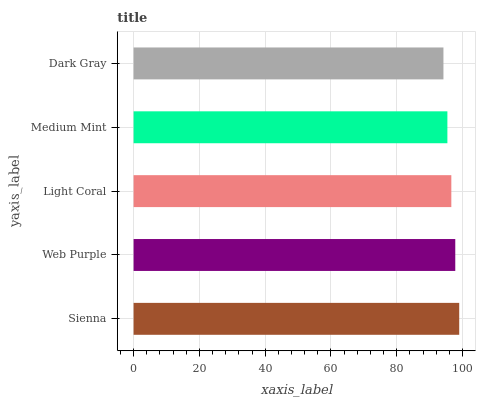Is Dark Gray the minimum?
Answer yes or no. Yes. Is Sienna the maximum?
Answer yes or no. Yes. Is Web Purple the minimum?
Answer yes or no. No. Is Web Purple the maximum?
Answer yes or no. No. Is Sienna greater than Web Purple?
Answer yes or no. Yes. Is Web Purple less than Sienna?
Answer yes or no. Yes. Is Web Purple greater than Sienna?
Answer yes or no. No. Is Sienna less than Web Purple?
Answer yes or no. No. Is Light Coral the high median?
Answer yes or no. Yes. Is Light Coral the low median?
Answer yes or no. Yes. Is Web Purple the high median?
Answer yes or no. No. Is Medium Mint the low median?
Answer yes or no. No. 